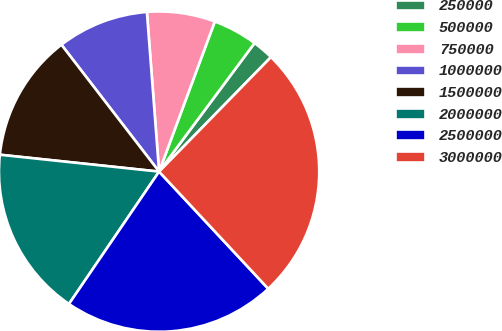Convert chart to OTSL. <chart><loc_0><loc_0><loc_500><loc_500><pie_chart><fcel>250000<fcel>500000<fcel>750000<fcel>1000000<fcel>1500000<fcel>2000000<fcel>2500000<fcel>3000000<nl><fcel>2.15%<fcel>4.51%<fcel>6.87%<fcel>9.23%<fcel>12.88%<fcel>17.17%<fcel>21.46%<fcel>25.75%<nl></chart> 